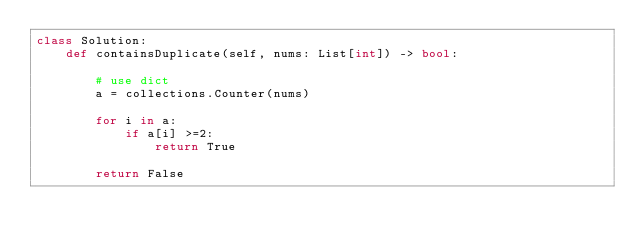Convert code to text. <code><loc_0><loc_0><loc_500><loc_500><_Python_>class Solution:
    def containsDuplicate(self, nums: List[int]) -> bool:
        
        # use dict
        a = collections.Counter(nums)
        
        for i in a:
            if a[i] >=2:
                return True
        
        return False
        
</code> 